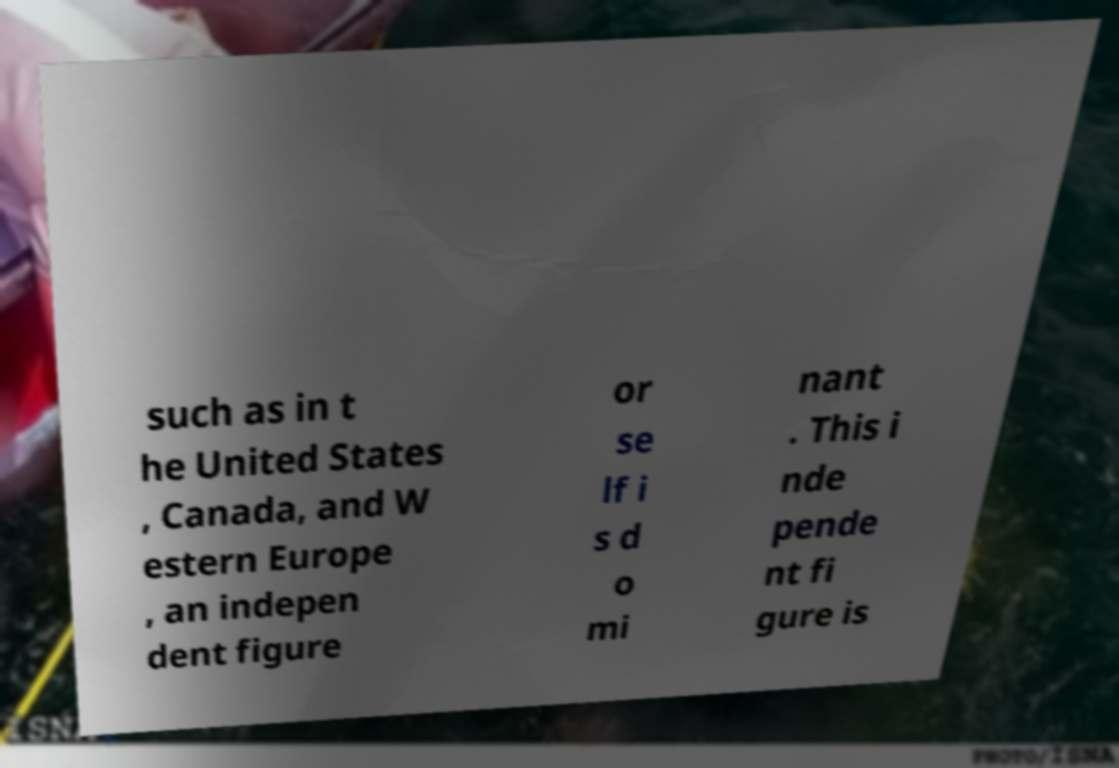For documentation purposes, I need the text within this image transcribed. Could you provide that? such as in t he United States , Canada, and W estern Europe , an indepen dent figure or se lf i s d o mi nant . This i nde pende nt fi gure is 